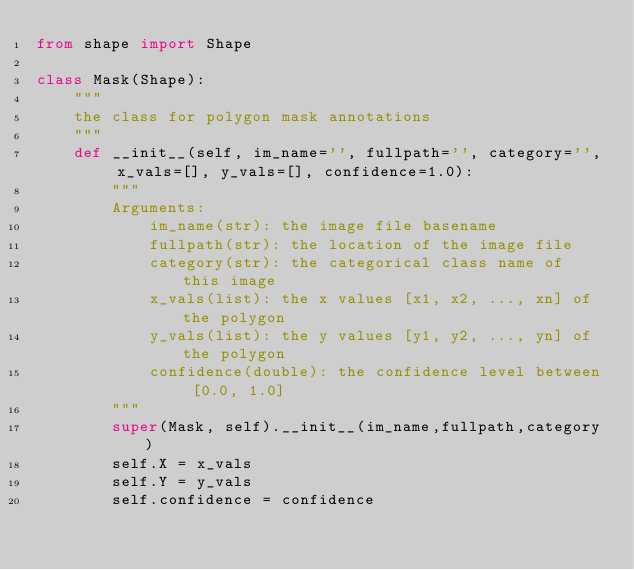Convert code to text. <code><loc_0><loc_0><loc_500><loc_500><_Python_>from shape import Shape

class Mask(Shape):
    """
    the class for polygon mask annotations
    """
    def __init__(self, im_name='', fullpath='', category='', x_vals=[], y_vals=[], confidence=1.0):
        """
        Arguments:
            im_name(str): the image file basename
            fullpath(str): the location of the image file
            category(str): the categorical class name of this image
            x_vals(list): the x values [x1, x2, ..., xn] of the polygon
            y_vals(list): the y values [y1, y2, ..., yn] of the polygon
            confidence(double): the confidence level between [0.0, 1.0] 
        """
        super(Mask, self).__init__(im_name,fullpath,category)
        self.X = x_vals
        self.Y = y_vals
        self.confidence = confidence
</code> 